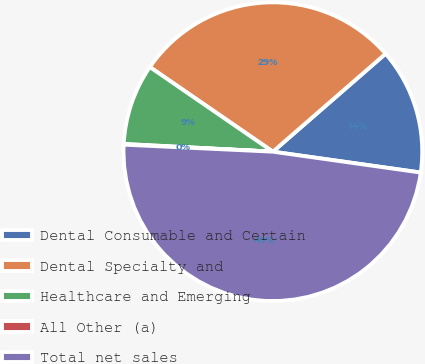Convert chart. <chart><loc_0><loc_0><loc_500><loc_500><pie_chart><fcel>Dental Consumable and Certain<fcel>Dental Specialty and<fcel>Healthcare and Emerging<fcel>All Other (a)<fcel>Total net sales<nl><fcel>13.62%<fcel>29.02%<fcel>8.77%<fcel>0.07%<fcel>48.52%<nl></chart> 